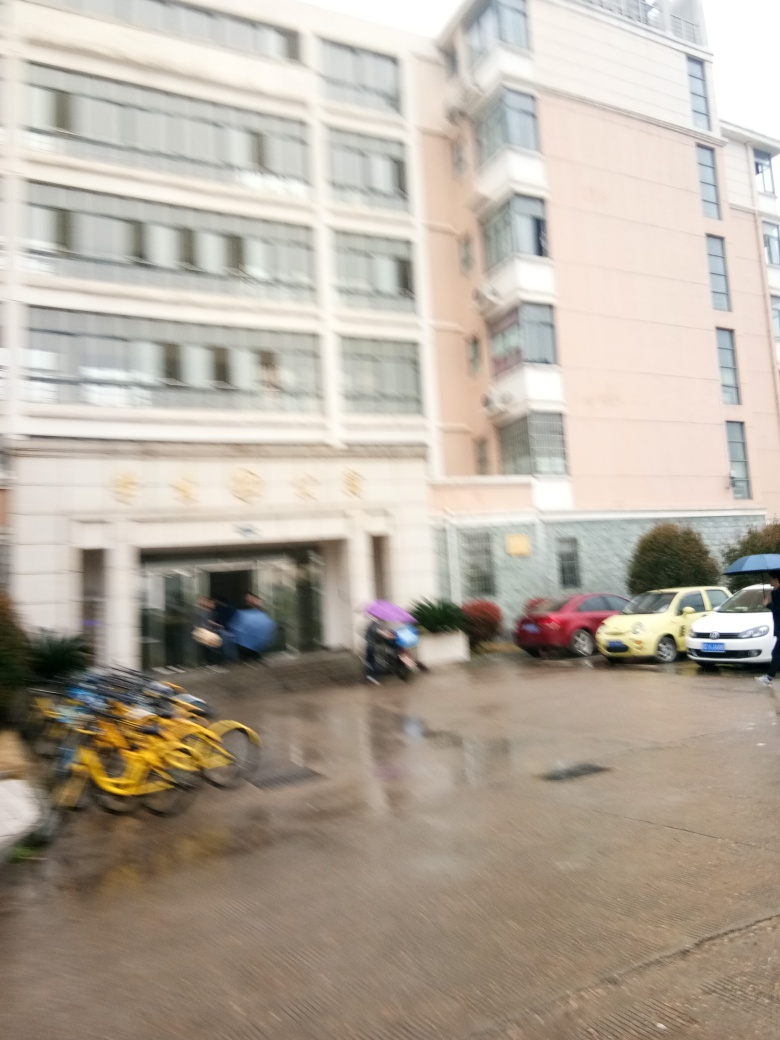What does this image tell us about the weather at the time the photo was taken? The image shows a wet ground and puddles, hinting at recent rainfall. Moreover, the overcast sky and the fact that some individuals seem to be using umbrellas further corroborate that it was likely raining around the time the photograph was captured. 